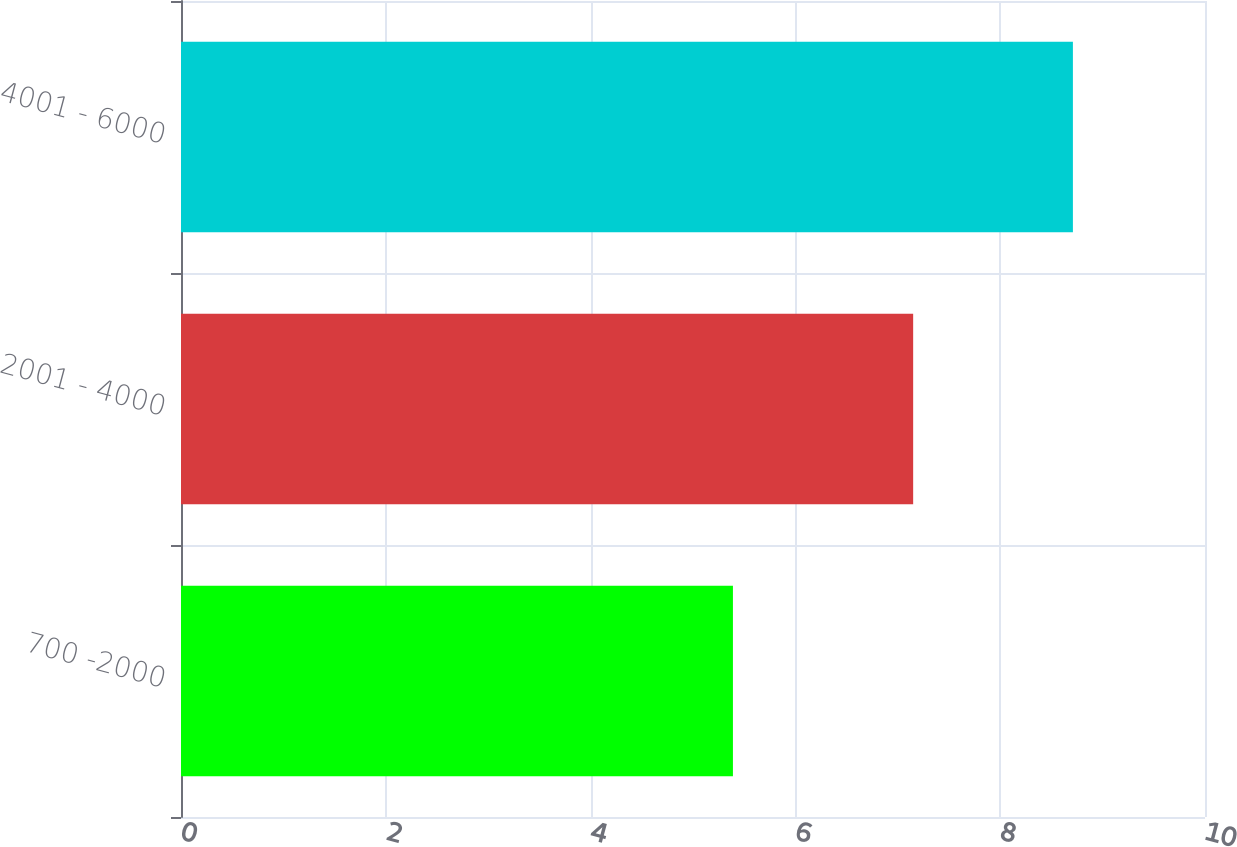<chart> <loc_0><loc_0><loc_500><loc_500><bar_chart><fcel>700 -2000<fcel>2001 - 4000<fcel>4001 - 6000<nl><fcel>5.39<fcel>7.15<fcel>8.71<nl></chart> 